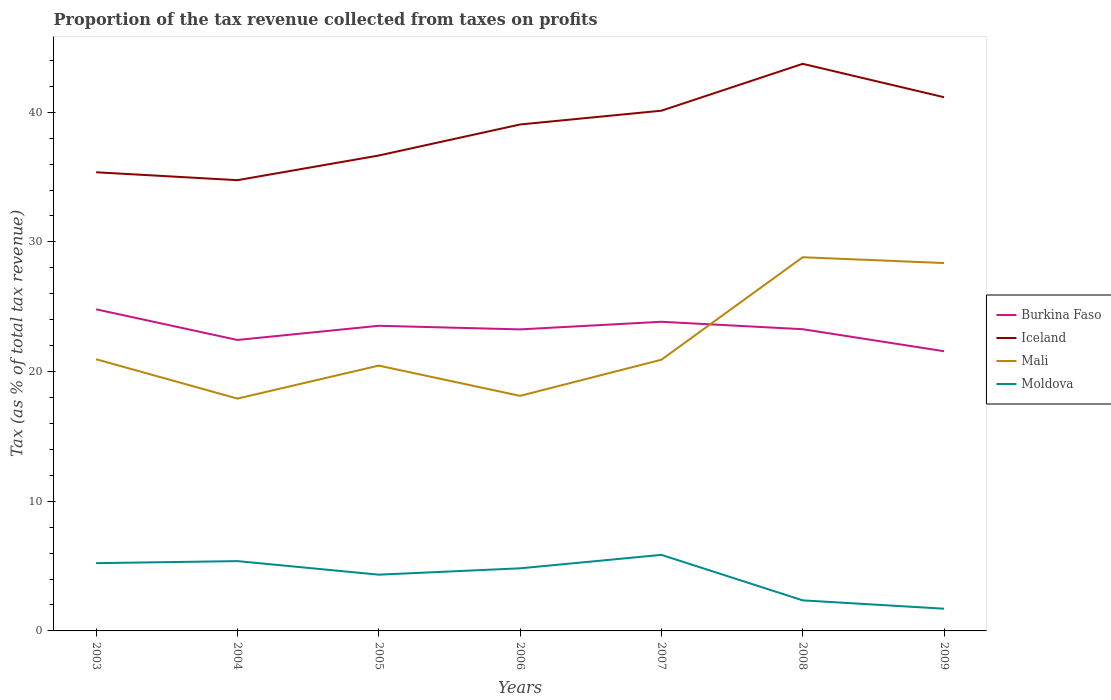Is the number of lines equal to the number of legend labels?
Provide a short and direct response. Yes. Across all years, what is the maximum proportion of the tax revenue collected in Burkina Faso?
Your answer should be compact. 21.57. In which year was the proportion of the tax revenue collected in Burkina Faso maximum?
Offer a very short reply. 2009. What is the total proportion of the tax revenue collected in Burkina Faso in the graph?
Offer a terse response. 1.54. What is the difference between the highest and the second highest proportion of the tax revenue collected in Mali?
Make the answer very short. 10.9. What is the difference between the highest and the lowest proportion of the tax revenue collected in Mali?
Give a very brief answer. 2. How many lines are there?
Offer a very short reply. 4. What is the difference between two consecutive major ticks on the Y-axis?
Ensure brevity in your answer.  10. Are the values on the major ticks of Y-axis written in scientific E-notation?
Provide a succinct answer. No. Where does the legend appear in the graph?
Your answer should be compact. Center right. How many legend labels are there?
Your response must be concise. 4. How are the legend labels stacked?
Keep it short and to the point. Vertical. What is the title of the graph?
Your response must be concise. Proportion of the tax revenue collected from taxes on profits. Does "Latin America(developing only)" appear as one of the legend labels in the graph?
Make the answer very short. No. What is the label or title of the X-axis?
Provide a short and direct response. Years. What is the label or title of the Y-axis?
Offer a very short reply. Tax (as % of total tax revenue). What is the Tax (as % of total tax revenue) of Burkina Faso in 2003?
Keep it short and to the point. 24.8. What is the Tax (as % of total tax revenue) in Iceland in 2003?
Make the answer very short. 35.37. What is the Tax (as % of total tax revenue) of Mali in 2003?
Offer a very short reply. 20.95. What is the Tax (as % of total tax revenue) of Moldova in 2003?
Keep it short and to the point. 5.23. What is the Tax (as % of total tax revenue) in Burkina Faso in 2004?
Offer a very short reply. 22.44. What is the Tax (as % of total tax revenue) of Iceland in 2004?
Offer a terse response. 34.76. What is the Tax (as % of total tax revenue) of Mali in 2004?
Give a very brief answer. 17.92. What is the Tax (as % of total tax revenue) of Moldova in 2004?
Offer a terse response. 5.38. What is the Tax (as % of total tax revenue) of Burkina Faso in 2005?
Provide a succinct answer. 23.53. What is the Tax (as % of total tax revenue) of Iceland in 2005?
Provide a short and direct response. 36.66. What is the Tax (as % of total tax revenue) of Mali in 2005?
Offer a very short reply. 20.46. What is the Tax (as % of total tax revenue) of Moldova in 2005?
Ensure brevity in your answer.  4.34. What is the Tax (as % of total tax revenue) of Burkina Faso in 2006?
Your response must be concise. 23.26. What is the Tax (as % of total tax revenue) of Iceland in 2006?
Offer a very short reply. 39.06. What is the Tax (as % of total tax revenue) in Mali in 2006?
Offer a very short reply. 18.13. What is the Tax (as % of total tax revenue) in Moldova in 2006?
Offer a very short reply. 4.83. What is the Tax (as % of total tax revenue) of Burkina Faso in 2007?
Ensure brevity in your answer.  23.84. What is the Tax (as % of total tax revenue) of Iceland in 2007?
Offer a very short reply. 40.12. What is the Tax (as % of total tax revenue) of Mali in 2007?
Your response must be concise. 20.91. What is the Tax (as % of total tax revenue) of Moldova in 2007?
Your answer should be very brief. 5.87. What is the Tax (as % of total tax revenue) in Burkina Faso in 2008?
Your answer should be very brief. 23.27. What is the Tax (as % of total tax revenue) in Iceland in 2008?
Give a very brief answer. 43.74. What is the Tax (as % of total tax revenue) of Mali in 2008?
Provide a short and direct response. 28.82. What is the Tax (as % of total tax revenue) of Moldova in 2008?
Provide a succinct answer. 2.36. What is the Tax (as % of total tax revenue) in Burkina Faso in 2009?
Provide a succinct answer. 21.57. What is the Tax (as % of total tax revenue) of Iceland in 2009?
Keep it short and to the point. 41.16. What is the Tax (as % of total tax revenue) in Mali in 2009?
Offer a very short reply. 28.37. What is the Tax (as % of total tax revenue) in Moldova in 2009?
Ensure brevity in your answer.  1.71. Across all years, what is the maximum Tax (as % of total tax revenue) of Burkina Faso?
Offer a very short reply. 24.8. Across all years, what is the maximum Tax (as % of total tax revenue) in Iceland?
Provide a short and direct response. 43.74. Across all years, what is the maximum Tax (as % of total tax revenue) in Mali?
Keep it short and to the point. 28.82. Across all years, what is the maximum Tax (as % of total tax revenue) of Moldova?
Give a very brief answer. 5.87. Across all years, what is the minimum Tax (as % of total tax revenue) in Burkina Faso?
Your answer should be compact. 21.57. Across all years, what is the minimum Tax (as % of total tax revenue) in Iceland?
Ensure brevity in your answer.  34.76. Across all years, what is the minimum Tax (as % of total tax revenue) of Mali?
Provide a succinct answer. 17.92. Across all years, what is the minimum Tax (as % of total tax revenue) in Moldova?
Your answer should be very brief. 1.71. What is the total Tax (as % of total tax revenue) in Burkina Faso in the graph?
Give a very brief answer. 162.71. What is the total Tax (as % of total tax revenue) of Iceland in the graph?
Your answer should be compact. 270.88. What is the total Tax (as % of total tax revenue) of Mali in the graph?
Give a very brief answer. 155.57. What is the total Tax (as % of total tax revenue) in Moldova in the graph?
Provide a succinct answer. 29.71. What is the difference between the Tax (as % of total tax revenue) of Burkina Faso in 2003 and that in 2004?
Offer a very short reply. 2.36. What is the difference between the Tax (as % of total tax revenue) in Iceland in 2003 and that in 2004?
Offer a very short reply. 0.61. What is the difference between the Tax (as % of total tax revenue) of Mali in 2003 and that in 2004?
Provide a succinct answer. 3.03. What is the difference between the Tax (as % of total tax revenue) of Moldova in 2003 and that in 2004?
Give a very brief answer. -0.16. What is the difference between the Tax (as % of total tax revenue) of Burkina Faso in 2003 and that in 2005?
Offer a terse response. 1.27. What is the difference between the Tax (as % of total tax revenue) in Iceland in 2003 and that in 2005?
Give a very brief answer. -1.29. What is the difference between the Tax (as % of total tax revenue) in Mali in 2003 and that in 2005?
Your response must be concise. 0.49. What is the difference between the Tax (as % of total tax revenue) of Moldova in 2003 and that in 2005?
Provide a succinct answer. 0.89. What is the difference between the Tax (as % of total tax revenue) in Burkina Faso in 2003 and that in 2006?
Make the answer very short. 1.55. What is the difference between the Tax (as % of total tax revenue) of Iceland in 2003 and that in 2006?
Make the answer very short. -3.69. What is the difference between the Tax (as % of total tax revenue) of Mali in 2003 and that in 2006?
Provide a succinct answer. 2.82. What is the difference between the Tax (as % of total tax revenue) of Moldova in 2003 and that in 2006?
Your answer should be very brief. 0.4. What is the difference between the Tax (as % of total tax revenue) in Burkina Faso in 2003 and that in 2007?
Provide a short and direct response. 0.96. What is the difference between the Tax (as % of total tax revenue) in Iceland in 2003 and that in 2007?
Give a very brief answer. -4.75. What is the difference between the Tax (as % of total tax revenue) in Mali in 2003 and that in 2007?
Your answer should be compact. 0.04. What is the difference between the Tax (as % of total tax revenue) of Moldova in 2003 and that in 2007?
Offer a very short reply. -0.64. What is the difference between the Tax (as % of total tax revenue) in Burkina Faso in 2003 and that in 2008?
Offer a terse response. 1.54. What is the difference between the Tax (as % of total tax revenue) in Iceland in 2003 and that in 2008?
Keep it short and to the point. -8.36. What is the difference between the Tax (as % of total tax revenue) of Mali in 2003 and that in 2008?
Your answer should be compact. -7.87. What is the difference between the Tax (as % of total tax revenue) of Moldova in 2003 and that in 2008?
Keep it short and to the point. 2.87. What is the difference between the Tax (as % of total tax revenue) of Burkina Faso in 2003 and that in 2009?
Your answer should be compact. 3.23. What is the difference between the Tax (as % of total tax revenue) of Iceland in 2003 and that in 2009?
Ensure brevity in your answer.  -5.79. What is the difference between the Tax (as % of total tax revenue) in Mali in 2003 and that in 2009?
Give a very brief answer. -7.42. What is the difference between the Tax (as % of total tax revenue) in Moldova in 2003 and that in 2009?
Provide a short and direct response. 3.51. What is the difference between the Tax (as % of total tax revenue) of Burkina Faso in 2004 and that in 2005?
Ensure brevity in your answer.  -1.09. What is the difference between the Tax (as % of total tax revenue) in Iceland in 2004 and that in 2005?
Offer a very short reply. -1.9. What is the difference between the Tax (as % of total tax revenue) of Mali in 2004 and that in 2005?
Offer a very short reply. -2.54. What is the difference between the Tax (as % of total tax revenue) in Moldova in 2004 and that in 2005?
Offer a terse response. 1.05. What is the difference between the Tax (as % of total tax revenue) in Burkina Faso in 2004 and that in 2006?
Give a very brief answer. -0.82. What is the difference between the Tax (as % of total tax revenue) of Iceland in 2004 and that in 2006?
Make the answer very short. -4.3. What is the difference between the Tax (as % of total tax revenue) of Mali in 2004 and that in 2006?
Offer a terse response. -0.21. What is the difference between the Tax (as % of total tax revenue) in Moldova in 2004 and that in 2006?
Make the answer very short. 0.56. What is the difference between the Tax (as % of total tax revenue) in Burkina Faso in 2004 and that in 2007?
Your answer should be very brief. -1.4. What is the difference between the Tax (as % of total tax revenue) of Iceland in 2004 and that in 2007?
Your answer should be compact. -5.36. What is the difference between the Tax (as % of total tax revenue) of Mali in 2004 and that in 2007?
Provide a short and direct response. -3. What is the difference between the Tax (as % of total tax revenue) in Moldova in 2004 and that in 2007?
Make the answer very short. -0.48. What is the difference between the Tax (as % of total tax revenue) in Burkina Faso in 2004 and that in 2008?
Your answer should be very brief. -0.83. What is the difference between the Tax (as % of total tax revenue) in Iceland in 2004 and that in 2008?
Offer a very short reply. -8.97. What is the difference between the Tax (as % of total tax revenue) of Mali in 2004 and that in 2008?
Offer a very short reply. -10.9. What is the difference between the Tax (as % of total tax revenue) of Moldova in 2004 and that in 2008?
Offer a very short reply. 3.03. What is the difference between the Tax (as % of total tax revenue) in Burkina Faso in 2004 and that in 2009?
Give a very brief answer. 0.87. What is the difference between the Tax (as % of total tax revenue) of Iceland in 2004 and that in 2009?
Your answer should be compact. -6.4. What is the difference between the Tax (as % of total tax revenue) in Mali in 2004 and that in 2009?
Your answer should be compact. -10.45. What is the difference between the Tax (as % of total tax revenue) of Moldova in 2004 and that in 2009?
Your answer should be very brief. 3.67. What is the difference between the Tax (as % of total tax revenue) in Burkina Faso in 2005 and that in 2006?
Make the answer very short. 0.28. What is the difference between the Tax (as % of total tax revenue) of Iceland in 2005 and that in 2006?
Your answer should be very brief. -2.39. What is the difference between the Tax (as % of total tax revenue) in Mali in 2005 and that in 2006?
Keep it short and to the point. 2.33. What is the difference between the Tax (as % of total tax revenue) of Moldova in 2005 and that in 2006?
Make the answer very short. -0.49. What is the difference between the Tax (as % of total tax revenue) of Burkina Faso in 2005 and that in 2007?
Provide a succinct answer. -0.31. What is the difference between the Tax (as % of total tax revenue) in Iceland in 2005 and that in 2007?
Offer a very short reply. -3.46. What is the difference between the Tax (as % of total tax revenue) of Mali in 2005 and that in 2007?
Provide a short and direct response. -0.45. What is the difference between the Tax (as % of total tax revenue) of Moldova in 2005 and that in 2007?
Offer a terse response. -1.53. What is the difference between the Tax (as % of total tax revenue) in Burkina Faso in 2005 and that in 2008?
Ensure brevity in your answer.  0.26. What is the difference between the Tax (as % of total tax revenue) in Iceland in 2005 and that in 2008?
Give a very brief answer. -7.07. What is the difference between the Tax (as % of total tax revenue) in Mali in 2005 and that in 2008?
Your answer should be compact. -8.36. What is the difference between the Tax (as % of total tax revenue) in Moldova in 2005 and that in 2008?
Your answer should be compact. 1.98. What is the difference between the Tax (as % of total tax revenue) in Burkina Faso in 2005 and that in 2009?
Provide a short and direct response. 1.96. What is the difference between the Tax (as % of total tax revenue) in Iceland in 2005 and that in 2009?
Give a very brief answer. -4.5. What is the difference between the Tax (as % of total tax revenue) of Mali in 2005 and that in 2009?
Give a very brief answer. -7.91. What is the difference between the Tax (as % of total tax revenue) of Moldova in 2005 and that in 2009?
Offer a very short reply. 2.62. What is the difference between the Tax (as % of total tax revenue) of Burkina Faso in 2006 and that in 2007?
Offer a very short reply. -0.59. What is the difference between the Tax (as % of total tax revenue) in Iceland in 2006 and that in 2007?
Provide a short and direct response. -1.06. What is the difference between the Tax (as % of total tax revenue) of Mali in 2006 and that in 2007?
Your answer should be compact. -2.79. What is the difference between the Tax (as % of total tax revenue) in Moldova in 2006 and that in 2007?
Keep it short and to the point. -1.04. What is the difference between the Tax (as % of total tax revenue) of Burkina Faso in 2006 and that in 2008?
Your answer should be very brief. -0.01. What is the difference between the Tax (as % of total tax revenue) of Iceland in 2006 and that in 2008?
Offer a very short reply. -4.68. What is the difference between the Tax (as % of total tax revenue) of Mali in 2006 and that in 2008?
Offer a very short reply. -10.69. What is the difference between the Tax (as % of total tax revenue) in Moldova in 2006 and that in 2008?
Keep it short and to the point. 2.47. What is the difference between the Tax (as % of total tax revenue) in Burkina Faso in 2006 and that in 2009?
Your answer should be compact. 1.68. What is the difference between the Tax (as % of total tax revenue) in Iceland in 2006 and that in 2009?
Offer a very short reply. -2.1. What is the difference between the Tax (as % of total tax revenue) in Mali in 2006 and that in 2009?
Offer a very short reply. -10.24. What is the difference between the Tax (as % of total tax revenue) of Moldova in 2006 and that in 2009?
Offer a terse response. 3.12. What is the difference between the Tax (as % of total tax revenue) of Burkina Faso in 2007 and that in 2008?
Provide a succinct answer. 0.57. What is the difference between the Tax (as % of total tax revenue) in Iceland in 2007 and that in 2008?
Your response must be concise. -3.62. What is the difference between the Tax (as % of total tax revenue) in Mali in 2007 and that in 2008?
Offer a terse response. -7.91. What is the difference between the Tax (as % of total tax revenue) of Moldova in 2007 and that in 2008?
Your answer should be very brief. 3.51. What is the difference between the Tax (as % of total tax revenue) of Burkina Faso in 2007 and that in 2009?
Provide a succinct answer. 2.27. What is the difference between the Tax (as % of total tax revenue) of Iceland in 2007 and that in 2009?
Your answer should be compact. -1.04. What is the difference between the Tax (as % of total tax revenue) of Mali in 2007 and that in 2009?
Provide a short and direct response. -7.46. What is the difference between the Tax (as % of total tax revenue) of Moldova in 2007 and that in 2009?
Keep it short and to the point. 4.15. What is the difference between the Tax (as % of total tax revenue) of Burkina Faso in 2008 and that in 2009?
Provide a succinct answer. 1.7. What is the difference between the Tax (as % of total tax revenue) in Iceland in 2008 and that in 2009?
Offer a terse response. 2.58. What is the difference between the Tax (as % of total tax revenue) in Mali in 2008 and that in 2009?
Offer a terse response. 0.45. What is the difference between the Tax (as % of total tax revenue) in Moldova in 2008 and that in 2009?
Make the answer very short. 0.64. What is the difference between the Tax (as % of total tax revenue) in Burkina Faso in 2003 and the Tax (as % of total tax revenue) in Iceland in 2004?
Your answer should be compact. -9.96. What is the difference between the Tax (as % of total tax revenue) of Burkina Faso in 2003 and the Tax (as % of total tax revenue) of Mali in 2004?
Keep it short and to the point. 6.89. What is the difference between the Tax (as % of total tax revenue) in Burkina Faso in 2003 and the Tax (as % of total tax revenue) in Moldova in 2004?
Provide a short and direct response. 19.42. What is the difference between the Tax (as % of total tax revenue) of Iceland in 2003 and the Tax (as % of total tax revenue) of Mali in 2004?
Provide a succinct answer. 17.45. What is the difference between the Tax (as % of total tax revenue) in Iceland in 2003 and the Tax (as % of total tax revenue) in Moldova in 2004?
Provide a short and direct response. 29.99. What is the difference between the Tax (as % of total tax revenue) in Mali in 2003 and the Tax (as % of total tax revenue) in Moldova in 2004?
Your response must be concise. 15.57. What is the difference between the Tax (as % of total tax revenue) of Burkina Faso in 2003 and the Tax (as % of total tax revenue) of Iceland in 2005?
Provide a short and direct response. -11.86. What is the difference between the Tax (as % of total tax revenue) of Burkina Faso in 2003 and the Tax (as % of total tax revenue) of Mali in 2005?
Give a very brief answer. 4.34. What is the difference between the Tax (as % of total tax revenue) in Burkina Faso in 2003 and the Tax (as % of total tax revenue) in Moldova in 2005?
Your answer should be compact. 20.47. What is the difference between the Tax (as % of total tax revenue) in Iceland in 2003 and the Tax (as % of total tax revenue) in Mali in 2005?
Offer a very short reply. 14.91. What is the difference between the Tax (as % of total tax revenue) in Iceland in 2003 and the Tax (as % of total tax revenue) in Moldova in 2005?
Make the answer very short. 31.03. What is the difference between the Tax (as % of total tax revenue) of Mali in 2003 and the Tax (as % of total tax revenue) of Moldova in 2005?
Provide a short and direct response. 16.62. What is the difference between the Tax (as % of total tax revenue) of Burkina Faso in 2003 and the Tax (as % of total tax revenue) of Iceland in 2006?
Give a very brief answer. -14.25. What is the difference between the Tax (as % of total tax revenue) of Burkina Faso in 2003 and the Tax (as % of total tax revenue) of Mali in 2006?
Make the answer very short. 6.68. What is the difference between the Tax (as % of total tax revenue) of Burkina Faso in 2003 and the Tax (as % of total tax revenue) of Moldova in 2006?
Make the answer very short. 19.98. What is the difference between the Tax (as % of total tax revenue) of Iceland in 2003 and the Tax (as % of total tax revenue) of Mali in 2006?
Keep it short and to the point. 17.24. What is the difference between the Tax (as % of total tax revenue) in Iceland in 2003 and the Tax (as % of total tax revenue) in Moldova in 2006?
Your answer should be very brief. 30.54. What is the difference between the Tax (as % of total tax revenue) of Mali in 2003 and the Tax (as % of total tax revenue) of Moldova in 2006?
Offer a very short reply. 16.12. What is the difference between the Tax (as % of total tax revenue) of Burkina Faso in 2003 and the Tax (as % of total tax revenue) of Iceland in 2007?
Keep it short and to the point. -15.32. What is the difference between the Tax (as % of total tax revenue) in Burkina Faso in 2003 and the Tax (as % of total tax revenue) in Mali in 2007?
Ensure brevity in your answer.  3.89. What is the difference between the Tax (as % of total tax revenue) of Burkina Faso in 2003 and the Tax (as % of total tax revenue) of Moldova in 2007?
Your answer should be very brief. 18.94. What is the difference between the Tax (as % of total tax revenue) in Iceland in 2003 and the Tax (as % of total tax revenue) in Mali in 2007?
Ensure brevity in your answer.  14.46. What is the difference between the Tax (as % of total tax revenue) in Iceland in 2003 and the Tax (as % of total tax revenue) in Moldova in 2007?
Keep it short and to the point. 29.51. What is the difference between the Tax (as % of total tax revenue) in Mali in 2003 and the Tax (as % of total tax revenue) in Moldova in 2007?
Provide a short and direct response. 15.09. What is the difference between the Tax (as % of total tax revenue) in Burkina Faso in 2003 and the Tax (as % of total tax revenue) in Iceland in 2008?
Offer a very short reply. -18.93. What is the difference between the Tax (as % of total tax revenue) of Burkina Faso in 2003 and the Tax (as % of total tax revenue) of Mali in 2008?
Offer a very short reply. -4.02. What is the difference between the Tax (as % of total tax revenue) of Burkina Faso in 2003 and the Tax (as % of total tax revenue) of Moldova in 2008?
Your response must be concise. 22.45. What is the difference between the Tax (as % of total tax revenue) in Iceland in 2003 and the Tax (as % of total tax revenue) in Mali in 2008?
Offer a terse response. 6.55. What is the difference between the Tax (as % of total tax revenue) in Iceland in 2003 and the Tax (as % of total tax revenue) in Moldova in 2008?
Offer a very short reply. 33.02. What is the difference between the Tax (as % of total tax revenue) in Mali in 2003 and the Tax (as % of total tax revenue) in Moldova in 2008?
Make the answer very short. 18.6. What is the difference between the Tax (as % of total tax revenue) of Burkina Faso in 2003 and the Tax (as % of total tax revenue) of Iceland in 2009?
Give a very brief answer. -16.36. What is the difference between the Tax (as % of total tax revenue) of Burkina Faso in 2003 and the Tax (as % of total tax revenue) of Mali in 2009?
Provide a short and direct response. -3.57. What is the difference between the Tax (as % of total tax revenue) of Burkina Faso in 2003 and the Tax (as % of total tax revenue) of Moldova in 2009?
Ensure brevity in your answer.  23.09. What is the difference between the Tax (as % of total tax revenue) of Iceland in 2003 and the Tax (as % of total tax revenue) of Mali in 2009?
Offer a very short reply. 7. What is the difference between the Tax (as % of total tax revenue) in Iceland in 2003 and the Tax (as % of total tax revenue) in Moldova in 2009?
Your response must be concise. 33.66. What is the difference between the Tax (as % of total tax revenue) of Mali in 2003 and the Tax (as % of total tax revenue) of Moldova in 2009?
Give a very brief answer. 19.24. What is the difference between the Tax (as % of total tax revenue) of Burkina Faso in 2004 and the Tax (as % of total tax revenue) of Iceland in 2005?
Ensure brevity in your answer.  -14.23. What is the difference between the Tax (as % of total tax revenue) of Burkina Faso in 2004 and the Tax (as % of total tax revenue) of Mali in 2005?
Offer a very short reply. 1.98. What is the difference between the Tax (as % of total tax revenue) of Burkina Faso in 2004 and the Tax (as % of total tax revenue) of Moldova in 2005?
Offer a very short reply. 18.1. What is the difference between the Tax (as % of total tax revenue) of Iceland in 2004 and the Tax (as % of total tax revenue) of Mali in 2005?
Ensure brevity in your answer.  14.3. What is the difference between the Tax (as % of total tax revenue) in Iceland in 2004 and the Tax (as % of total tax revenue) in Moldova in 2005?
Make the answer very short. 30.43. What is the difference between the Tax (as % of total tax revenue) of Mali in 2004 and the Tax (as % of total tax revenue) of Moldova in 2005?
Provide a short and direct response. 13.58. What is the difference between the Tax (as % of total tax revenue) in Burkina Faso in 2004 and the Tax (as % of total tax revenue) in Iceland in 2006?
Give a very brief answer. -16.62. What is the difference between the Tax (as % of total tax revenue) in Burkina Faso in 2004 and the Tax (as % of total tax revenue) in Mali in 2006?
Give a very brief answer. 4.31. What is the difference between the Tax (as % of total tax revenue) in Burkina Faso in 2004 and the Tax (as % of total tax revenue) in Moldova in 2006?
Ensure brevity in your answer.  17.61. What is the difference between the Tax (as % of total tax revenue) in Iceland in 2004 and the Tax (as % of total tax revenue) in Mali in 2006?
Provide a short and direct response. 16.63. What is the difference between the Tax (as % of total tax revenue) of Iceland in 2004 and the Tax (as % of total tax revenue) of Moldova in 2006?
Your answer should be compact. 29.93. What is the difference between the Tax (as % of total tax revenue) in Mali in 2004 and the Tax (as % of total tax revenue) in Moldova in 2006?
Your answer should be very brief. 13.09. What is the difference between the Tax (as % of total tax revenue) in Burkina Faso in 2004 and the Tax (as % of total tax revenue) in Iceland in 2007?
Give a very brief answer. -17.68. What is the difference between the Tax (as % of total tax revenue) in Burkina Faso in 2004 and the Tax (as % of total tax revenue) in Mali in 2007?
Keep it short and to the point. 1.53. What is the difference between the Tax (as % of total tax revenue) of Burkina Faso in 2004 and the Tax (as % of total tax revenue) of Moldova in 2007?
Provide a short and direct response. 16.57. What is the difference between the Tax (as % of total tax revenue) of Iceland in 2004 and the Tax (as % of total tax revenue) of Mali in 2007?
Give a very brief answer. 13.85. What is the difference between the Tax (as % of total tax revenue) in Iceland in 2004 and the Tax (as % of total tax revenue) in Moldova in 2007?
Your answer should be compact. 28.9. What is the difference between the Tax (as % of total tax revenue) of Mali in 2004 and the Tax (as % of total tax revenue) of Moldova in 2007?
Provide a short and direct response. 12.05. What is the difference between the Tax (as % of total tax revenue) in Burkina Faso in 2004 and the Tax (as % of total tax revenue) in Iceland in 2008?
Offer a terse response. -21.3. What is the difference between the Tax (as % of total tax revenue) in Burkina Faso in 2004 and the Tax (as % of total tax revenue) in Mali in 2008?
Keep it short and to the point. -6.38. What is the difference between the Tax (as % of total tax revenue) in Burkina Faso in 2004 and the Tax (as % of total tax revenue) in Moldova in 2008?
Keep it short and to the point. 20.08. What is the difference between the Tax (as % of total tax revenue) in Iceland in 2004 and the Tax (as % of total tax revenue) in Mali in 2008?
Provide a short and direct response. 5.94. What is the difference between the Tax (as % of total tax revenue) in Iceland in 2004 and the Tax (as % of total tax revenue) in Moldova in 2008?
Give a very brief answer. 32.41. What is the difference between the Tax (as % of total tax revenue) of Mali in 2004 and the Tax (as % of total tax revenue) of Moldova in 2008?
Make the answer very short. 15.56. What is the difference between the Tax (as % of total tax revenue) of Burkina Faso in 2004 and the Tax (as % of total tax revenue) of Iceland in 2009?
Offer a very short reply. -18.72. What is the difference between the Tax (as % of total tax revenue) of Burkina Faso in 2004 and the Tax (as % of total tax revenue) of Mali in 2009?
Ensure brevity in your answer.  -5.93. What is the difference between the Tax (as % of total tax revenue) in Burkina Faso in 2004 and the Tax (as % of total tax revenue) in Moldova in 2009?
Offer a very short reply. 20.73. What is the difference between the Tax (as % of total tax revenue) of Iceland in 2004 and the Tax (as % of total tax revenue) of Mali in 2009?
Your answer should be compact. 6.39. What is the difference between the Tax (as % of total tax revenue) of Iceland in 2004 and the Tax (as % of total tax revenue) of Moldova in 2009?
Your answer should be compact. 33.05. What is the difference between the Tax (as % of total tax revenue) of Mali in 2004 and the Tax (as % of total tax revenue) of Moldova in 2009?
Provide a short and direct response. 16.21. What is the difference between the Tax (as % of total tax revenue) in Burkina Faso in 2005 and the Tax (as % of total tax revenue) in Iceland in 2006?
Provide a short and direct response. -15.53. What is the difference between the Tax (as % of total tax revenue) in Burkina Faso in 2005 and the Tax (as % of total tax revenue) in Mali in 2006?
Provide a short and direct response. 5.4. What is the difference between the Tax (as % of total tax revenue) of Burkina Faso in 2005 and the Tax (as % of total tax revenue) of Moldova in 2006?
Your answer should be very brief. 18.7. What is the difference between the Tax (as % of total tax revenue) in Iceland in 2005 and the Tax (as % of total tax revenue) in Mali in 2006?
Provide a succinct answer. 18.54. What is the difference between the Tax (as % of total tax revenue) in Iceland in 2005 and the Tax (as % of total tax revenue) in Moldova in 2006?
Your answer should be very brief. 31.84. What is the difference between the Tax (as % of total tax revenue) of Mali in 2005 and the Tax (as % of total tax revenue) of Moldova in 2006?
Make the answer very short. 15.63. What is the difference between the Tax (as % of total tax revenue) in Burkina Faso in 2005 and the Tax (as % of total tax revenue) in Iceland in 2007?
Your response must be concise. -16.59. What is the difference between the Tax (as % of total tax revenue) in Burkina Faso in 2005 and the Tax (as % of total tax revenue) in Mali in 2007?
Your response must be concise. 2.62. What is the difference between the Tax (as % of total tax revenue) of Burkina Faso in 2005 and the Tax (as % of total tax revenue) of Moldova in 2007?
Provide a short and direct response. 17.67. What is the difference between the Tax (as % of total tax revenue) of Iceland in 2005 and the Tax (as % of total tax revenue) of Mali in 2007?
Your answer should be compact. 15.75. What is the difference between the Tax (as % of total tax revenue) of Iceland in 2005 and the Tax (as % of total tax revenue) of Moldova in 2007?
Ensure brevity in your answer.  30.8. What is the difference between the Tax (as % of total tax revenue) of Mali in 2005 and the Tax (as % of total tax revenue) of Moldova in 2007?
Provide a succinct answer. 14.6. What is the difference between the Tax (as % of total tax revenue) of Burkina Faso in 2005 and the Tax (as % of total tax revenue) of Iceland in 2008?
Give a very brief answer. -20.2. What is the difference between the Tax (as % of total tax revenue) of Burkina Faso in 2005 and the Tax (as % of total tax revenue) of Mali in 2008?
Give a very brief answer. -5.29. What is the difference between the Tax (as % of total tax revenue) in Burkina Faso in 2005 and the Tax (as % of total tax revenue) in Moldova in 2008?
Ensure brevity in your answer.  21.18. What is the difference between the Tax (as % of total tax revenue) in Iceland in 2005 and the Tax (as % of total tax revenue) in Mali in 2008?
Make the answer very short. 7.84. What is the difference between the Tax (as % of total tax revenue) in Iceland in 2005 and the Tax (as % of total tax revenue) in Moldova in 2008?
Your answer should be compact. 34.31. What is the difference between the Tax (as % of total tax revenue) in Mali in 2005 and the Tax (as % of total tax revenue) in Moldova in 2008?
Give a very brief answer. 18.11. What is the difference between the Tax (as % of total tax revenue) of Burkina Faso in 2005 and the Tax (as % of total tax revenue) of Iceland in 2009?
Your answer should be compact. -17.63. What is the difference between the Tax (as % of total tax revenue) in Burkina Faso in 2005 and the Tax (as % of total tax revenue) in Mali in 2009?
Your answer should be very brief. -4.84. What is the difference between the Tax (as % of total tax revenue) in Burkina Faso in 2005 and the Tax (as % of total tax revenue) in Moldova in 2009?
Your answer should be very brief. 21.82. What is the difference between the Tax (as % of total tax revenue) in Iceland in 2005 and the Tax (as % of total tax revenue) in Mali in 2009?
Provide a succinct answer. 8.29. What is the difference between the Tax (as % of total tax revenue) in Iceland in 2005 and the Tax (as % of total tax revenue) in Moldova in 2009?
Keep it short and to the point. 34.95. What is the difference between the Tax (as % of total tax revenue) in Mali in 2005 and the Tax (as % of total tax revenue) in Moldova in 2009?
Keep it short and to the point. 18.75. What is the difference between the Tax (as % of total tax revenue) of Burkina Faso in 2006 and the Tax (as % of total tax revenue) of Iceland in 2007?
Your answer should be compact. -16.87. What is the difference between the Tax (as % of total tax revenue) of Burkina Faso in 2006 and the Tax (as % of total tax revenue) of Mali in 2007?
Offer a very short reply. 2.34. What is the difference between the Tax (as % of total tax revenue) in Burkina Faso in 2006 and the Tax (as % of total tax revenue) in Moldova in 2007?
Make the answer very short. 17.39. What is the difference between the Tax (as % of total tax revenue) in Iceland in 2006 and the Tax (as % of total tax revenue) in Mali in 2007?
Provide a succinct answer. 18.14. What is the difference between the Tax (as % of total tax revenue) in Iceland in 2006 and the Tax (as % of total tax revenue) in Moldova in 2007?
Provide a succinct answer. 33.19. What is the difference between the Tax (as % of total tax revenue) in Mali in 2006 and the Tax (as % of total tax revenue) in Moldova in 2007?
Your answer should be very brief. 12.26. What is the difference between the Tax (as % of total tax revenue) of Burkina Faso in 2006 and the Tax (as % of total tax revenue) of Iceland in 2008?
Your answer should be compact. -20.48. What is the difference between the Tax (as % of total tax revenue) in Burkina Faso in 2006 and the Tax (as % of total tax revenue) in Mali in 2008?
Your answer should be compact. -5.57. What is the difference between the Tax (as % of total tax revenue) in Burkina Faso in 2006 and the Tax (as % of total tax revenue) in Moldova in 2008?
Make the answer very short. 20.9. What is the difference between the Tax (as % of total tax revenue) in Iceland in 2006 and the Tax (as % of total tax revenue) in Mali in 2008?
Your response must be concise. 10.24. What is the difference between the Tax (as % of total tax revenue) in Iceland in 2006 and the Tax (as % of total tax revenue) in Moldova in 2008?
Provide a succinct answer. 36.7. What is the difference between the Tax (as % of total tax revenue) of Mali in 2006 and the Tax (as % of total tax revenue) of Moldova in 2008?
Give a very brief answer. 15.77. What is the difference between the Tax (as % of total tax revenue) of Burkina Faso in 2006 and the Tax (as % of total tax revenue) of Iceland in 2009?
Make the answer very short. -17.91. What is the difference between the Tax (as % of total tax revenue) of Burkina Faso in 2006 and the Tax (as % of total tax revenue) of Mali in 2009?
Give a very brief answer. -5.12. What is the difference between the Tax (as % of total tax revenue) of Burkina Faso in 2006 and the Tax (as % of total tax revenue) of Moldova in 2009?
Give a very brief answer. 21.54. What is the difference between the Tax (as % of total tax revenue) of Iceland in 2006 and the Tax (as % of total tax revenue) of Mali in 2009?
Your answer should be compact. 10.69. What is the difference between the Tax (as % of total tax revenue) in Iceland in 2006 and the Tax (as % of total tax revenue) in Moldova in 2009?
Offer a terse response. 37.35. What is the difference between the Tax (as % of total tax revenue) of Mali in 2006 and the Tax (as % of total tax revenue) of Moldova in 2009?
Ensure brevity in your answer.  16.42. What is the difference between the Tax (as % of total tax revenue) of Burkina Faso in 2007 and the Tax (as % of total tax revenue) of Iceland in 2008?
Your response must be concise. -19.89. What is the difference between the Tax (as % of total tax revenue) of Burkina Faso in 2007 and the Tax (as % of total tax revenue) of Mali in 2008?
Your answer should be compact. -4.98. What is the difference between the Tax (as % of total tax revenue) in Burkina Faso in 2007 and the Tax (as % of total tax revenue) in Moldova in 2008?
Keep it short and to the point. 21.48. What is the difference between the Tax (as % of total tax revenue) of Iceland in 2007 and the Tax (as % of total tax revenue) of Mali in 2008?
Keep it short and to the point. 11.3. What is the difference between the Tax (as % of total tax revenue) in Iceland in 2007 and the Tax (as % of total tax revenue) in Moldova in 2008?
Offer a very short reply. 37.76. What is the difference between the Tax (as % of total tax revenue) in Mali in 2007 and the Tax (as % of total tax revenue) in Moldova in 2008?
Ensure brevity in your answer.  18.56. What is the difference between the Tax (as % of total tax revenue) in Burkina Faso in 2007 and the Tax (as % of total tax revenue) in Iceland in 2009?
Keep it short and to the point. -17.32. What is the difference between the Tax (as % of total tax revenue) of Burkina Faso in 2007 and the Tax (as % of total tax revenue) of Mali in 2009?
Make the answer very short. -4.53. What is the difference between the Tax (as % of total tax revenue) in Burkina Faso in 2007 and the Tax (as % of total tax revenue) in Moldova in 2009?
Give a very brief answer. 22.13. What is the difference between the Tax (as % of total tax revenue) of Iceland in 2007 and the Tax (as % of total tax revenue) of Mali in 2009?
Your response must be concise. 11.75. What is the difference between the Tax (as % of total tax revenue) of Iceland in 2007 and the Tax (as % of total tax revenue) of Moldova in 2009?
Your answer should be compact. 38.41. What is the difference between the Tax (as % of total tax revenue) of Mali in 2007 and the Tax (as % of total tax revenue) of Moldova in 2009?
Give a very brief answer. 19.2. What is the difference between the Tax (as % of total tax revenue) in Burkina Faso in 2008 and the Tax (as % of total tax revenue) in Iceland in 2009?
Give a very brief answer. -17.89. What is the difference between the Tax (as % of total tax revenue) of Burkina Faso in 2008 and the Tax (as % of total tax revenue) of Mali in 2009?
Keep it short and to the point. -5.1. What is the difference between the Tax (as % of total tax revenue) in Burkina Faso in 2008 and the Tax (as % of total tax revenue) in Moldova in 2009?
Provide a succinct answer. 21.56. What is the difference between the Tax (as % of total tax revenue) of Iceland in 2008 and the Tax (as % of total tax revenue) of Mali in 2009?
Keep it short and to the point. 15.36. What is the difference between the Tax (as % of total tax revenue) of Iceland in 2008 and the Tax (as % of total tax revenue) of Moldova in 2009?
Your response must be concise. 42.02. What is the difference between the Tax (as % of total tax revenue) in Mali in 2008 and the Tax (as % of total tax revenue) in Moldova in 2009?
Make the answer very short. 27.11. What is the average Tax (as % of total tax revenue) of Burkina Faso per year?
Make the answer very short. 23.24. What is the average Tax (as % of total tax revenue) in Iceland per year?
Make the answer very short. 38.7. What is the average Tax (as % of total tax revenue) in Mali per year?
Offer a very short reply. 22.22. What is the average Tax (as % of total tax revenue) in Moldova per year?
Your answer should be compact. 4.24. In the year 2003, what is the difference between the Tax (as % of total tax revenue) of Burkina Faso and Tax (as % of total tax revenue) of Iceland?
Ensure brevity in your answer.  -10.57. In the year 2003, what is the difference between the Tax (as % of total tax revenue) in Burkina Faso and Tax (as % of total tax revenue) in Mali?
Provide a succinct answer. 3.85. In the year 2003, what is the difference between the Tax (as % of total tax revenue) of Burkina Faso and Tax (as % of total tax revenue) of Moldova?
Offer a terse response. 19.58. In the year 2003, what is the difference between the Tax (as % of total tax revenue) in Iceland and Tax (as % of total tax revenue) in Mali?
Ensure brevity in your answer.  14.42. In the year 2003, what is the difference between the Tax (as % of total tax revenue) of Iceland and Tax (as % of total tax revenue) of Moldova?
Provide a succinct answer. 30.15. In the year 2003, what is the difference between the Tax (as % of total tax revenue) in Mali and Tax (as % of total tax revenue) in Moldova?
Provide a succinct answer. 15.73. In the year 2004, what is the difference between the Tax (as % of total tax revenue) of Burkina Faso and Tax (as % of total tax revenue) of Iceland?
Provide a short and direct response. -12.32. In the year 2004, what is the difference between the Tax (as % of total tax revenue) of Burkina Faso and Tax (as % of total tax revenue) of Mali?
Offer a very short reply. 4.52. In the year 2004, what is the difference between the Tax (as % of total tax revenue) of Burkina Faso and Tax (as % of total tax revenue) of Moldova?
Give a very brief answer. 17.06. In the year 2004, what is the difference between the Tax (as % of total tax revenue) in Iceland and Tax (as % of total tax revenue) in Mali?
Ensure brevity in your answer.  16.84. In the year 2004, what is the difference between the Tax (as % of total tax revenue) in Iceland and Tax (as % of total tax revenue) in Moldova?
Your answer should be very brief. 29.38. In the year 2004, what is the difference between the Tax (as % of total tax revenue) in Mali and Tax (as % of total tax revenue) in Moldova?
Provide a short and direct response. 12.53. In the year 2005, what is the difference between the Tax (as % of total tax revenue) in Burkina Faso and Tax (as % of total tax revenue) in Iceland?
Offer a very short reply. -13.13. In the year 2005, what is the difference between the Tax (as % of total tax revenue) in Burkina Faso and Tax (as % of total tax revenue) in Mali?
Make the answer very short. 3.07. In the year 2005, what is the difference between the Tax (as % of total tax revenue) in Burkina Faso and Tax (as % of total tax revenue) in Moldova?
Offer a terse response. 19.2. In the year 2005, what is the difference between the Tax (as % of total tax revenue) of Iceland and Tax (as % of total tax revenue) of Mali?
Your answer should be very brief. 16.2. In the year 2005, what is the difference between the Tax (as % of total tax revenue) of Iceland and Tax (as % of total tax revenue) of Moldova?
Provide a succinct answer. 32.33. In the year 2005, what is the difference between the Tax (as % of total tax revenue) of Mali and Tax (as % of total tax revenue) of Moldova?
Provide a succinct answer. 16.12. In the year 2006, what is the difference between the Tax (as % of total tax revenue) in Burkina Faso and Tax (as % of total tax revenue) in Iceland?
Your answer should be compact. -15.8. In the year 2006, what is the difference between the Tax (as % of total tax revenue) of Burkina Faso and Tax (as % of total tax revenue) of Mali?
Make the answer very short. 5.13. In the year 2006, what is the difference between the Tax (as % of total tax revenue) in Burkina Faso and Tax (as % of total tax revenue) in Moldova?
Offer a terse response. 18.43. In the year 2006, what is the difference between the Tax (as % of total tax revenue) of Iceland and Tax (as % of total tax revenue) of Mali?
Your answer should be very brief. 20.93. In the year 2006, what is the difference between the Tax (as % of total tax revenue) of Iceland and Tax (as % of total tax revenue) of Moldova?
Provide a succinct answer. 34.23. In the year 2006, what is the difference between the Tax (as % of total tax revenue) of Mali and Tax (as % of total tax revenue) of Moldova?
Your answer should be very brief. 13.3. In the year 2007, what is the difference between the Tax (as % of total tax revenue) in Burkina Faso and Tax (as % of total tax revenue) in Iceland?
Your answer should be very brief. -16.28. In the year 2007, what is the difference between the Tax (as % of total tax revenue) in Burkina Faso and Tax (as % of total tax revenue) in Mali?
Give a very brief answer. 2.93. In the year 2007, what is the difference between the Tax (as % of total tax revenue) of Burkina Faso and Tax (as % of total tax revenue) of Moldova?
Ensure brevity in your answer.  17.98. In the year 2007, what is the difference between the Tax (as % of total tax revenue) of Iceland and Tax (as % of total tax revenue) of Mali?
Ensure brevity in your answer.  19.21. In the year 2007, what is the difference between the Tax (as % of total tax revenue) in Iceland and Tax (as % of total tax revenue) in Moldova?
Provide a short and direct response. 34.25. In the year 2007, what is the difference between the Tax (as % of total tax revenue) in Mali and Tax (as % of total tax revenue) in Moldova?
Ensure brevity in your answer.  15.05. In the year 2008, what is the difference between the Tax (as % of total tax revenue) of Burkina Faso and Tax (as % of total tax revenue) of Iceland?
Your answer should be very brief. -20.47. In the year 2008, what is the difference between the Tax (as % of total tax revenue) in Burkina Faso and Tax (as % of total tax revenue) in Mali?
Your answer should be compact. -5.55. In the year 2008, what is the difference between the Tax (as % of total tax revenue) in Burkina Faso and Tax (as % of total tax revenue) in Moldova?
Provide a succinct answer. 20.91. In the year 2008, what is the difference between the Tax (as % of total tax revenue) of Iceland and Tax (as % of total tax revenue) of Mali?
Provide a succinct answer. 14.92. In the year 2008, what is the difference between the Tax (as % of total tax revenue) of Iceland and Tax (as % of total tax revenue) of Moldova?
Keep it short and to the point. 41.38. In the year 2008, what is the difference between the Tax (as % of total tax revenue) in Mali and Tax (as % of total tax revenue) in Moldova?
Provide a short and direct response. 26.46. In the year 2009, what is the difference between the Tax (as % of total tax revenue) of Burkina Faso and Tax (as % of total tax revenue) of Iceland?
Your response must be concise. -19.59. In the year 2009, what is the difference between the Tax (as % of total tax revenue) of Burkina Faso and Tax (as % of total tax revenue) of Mali?
Make the answer very short. -6.8. In the year 2009, what is the difference between the Tax (as % of total tax revenue) of Burkina Faso and Tax (as % of total tax revenue) of Moldova?
Your answer should be compact. 19.86. In the year 2009, what is the difference between the Tax (as % of total tax revenue) in Iceland and Tax (as % of total tax revenue) in Mali?
Your answer should be compact. 12.79. In the year 2009, what is the difference between the Tax (as % of total tax revenue) of Iceland and Tax (as % of total tax revenue) of Moldova?
Keep it short and to the point. 39.45. In the year 2009, what is the difference between the Tax (as % of total tax revenue) in Mali and Tax (as % of total tax revenue) in Moldova?
Give a very brief answer. 26.66. What is the ratio of the Tax (as % of total tax revenue) of Burkina Faso in 2003 to that in 2004?
Keep it short and to the point. 1.11. What is the ratio of the Tax (as % of total tax revenue) in Iceland in 2003 to that in 2004?
Provide a short and direct response. 1.02. What is the ratio of the Tax (as % of total tax revenue) of Mali in 2003 to that in 2004?
Provide a succinct answer. 1.17. What is the ratio of the Tax (as % of total tax revenue) of Moldova in 2003 to that in 2004?
Make the answer very short. 0.97. What is the ratio of the Tax (as % of total tax revenue) of Burkina Faso in 2003 to that in 2005?
Provide a succinct answer. 1.05. What is the ratio of the Tax (as % of total tax revenue) in Iceland in 2003 to that in 2005?
Keep it short and to the point. 0.96. What is the ratio of the Tax (as % of total tax revenue) of Mali in 2003 to that in 2005?
Provide a short and direct response. 1.02. What is the ratio of the Tax (as % of total tax revenue) of Moldova in 2003 to that in 2005?
Your answer should be compact. 1.2. What is the ratio of the Tax (as % of total tax revenue) in Burkina Faso in 2003 to that in 2006?
Give a very brief answer. 1.07. What is the ratio of the Tax (as % of total tax revenue) in Iceland in 2003 to that in 2006?
Give a very brief answer. 0.91. What is the ratio of the Tax (as % of total tax revenue) in Mali in 2003 to that in 2006?
Offer a terse response. 1.16. What is the ratio of the Tax (as % of total tax revenue) of Moldova in 2003 to that in 2006?
Your response must be concise. 1.08. What is the ratio of the Tax (as % of total tax revenue) of Burkina Faso in 2003 to that in 2007?
Offer a terse response. 1.04. What is the ratio of the Tax (as % of total tax revenue) of Iceland in 2003 to that in 2007?
Keep it short and to the point. 0.88. What is the ratio of the Tax (as % of total tax revenue) of Mali in 2003 to that in 2007?
Your response must be concise. 1. What is the ratio of the Tax (as % of total tax revenue) in Moldova in 2003 to that in 2007?
Your response must be concise. 0.89. What is the ratio of the Tax (as % of total tax revenue) of Burkina Faso in 2003 to that in 2008?
Give a very brief answer. 1.07. What is the ratio of the Tax (as % of total tax revenue) in Iceland in 2003 to that in 2008?
Keep it short and to the point. 0.81. What is the ratio of the Tax (as % of total tax revenue) in Mali in 2003 to that in 2008?
Your answer should be very brief. 0.73. What is the ratio of the Tax (as % of total tax revenue) in Moldova in 2003 to that in 2008?
Offer a very short reply. 2.22. What is the ratio of the Tax (as % of total tax revenue) of Burkina Faso in 2003 to that in 2009?
Give a very brief answer. 1.15. What is the ratio of the Tax (as % of total tax revenue) of Iceland in 2003 to that in 2009?
Offer a terse response. 0.86. What is the ratio of the Tax (as % of total tax revenue) of Mali in 2003 to that in 2009?
Provide a short and direct response. 0.74. What is the ratio of the Tax (as % of total tax revenue) of Moldova in 2003 to that in 2009?
Keep it short and to the point. 3.05. What is the ratio of the Tax (as % of total tax revenue) of Burkina Faso in 2004 to that in 2005?
Ensure brevity in your answer.  0.95. What is the ratio of the Tax (as % of total tax revenue) of Iceland in 2004 to that in 2005?
Ensure brevity in your answer.  0.95. What is the ratio of the Tax (as % of total tax revenue) in Mali in 2004 to that in 2005?
Give a very brief answer. 0.88. What is the ratio of the Tax (as % of total tax revenue) in Moldova in 2004 to that in 2005?
Provide a short and direct response. 1.24. What is the ratio of the Tax (as % of total tax revenue) of Burkina Faso in 2004 to that in 2006?
Give a very brief answer. 0.96. What is the ratio of the Tax (as % of total tax revenue) of Iceland in 2004 to that in 2006?
Keep it short and to the point. 0.89. What is the ratio of the Tax (as % of total tax revenue) of Mali in 2004 to that in 2006?
Your answer should be compact. 0.99. What is the ratio of the Tax (as % of total tax revenue) in Moldova in 2004 to that in 2006?
Provide a short and direct response. 1.12. What is the ratio of the Tax (as % of total tax revenue) in Burkina Faso in 2004 to that in 2007?
Your answer should be compact. 0.94. What is the ratio of the Tax (as % of total tax revenue) in Iceland in 2004 to that in 2007?
Give a very brief answer. 0.87. What is the ratio of the Tax (as % of total tax revenue) in Mali in 2004 to that in 2007?
Offer a terse response. 0.86. What is the ratio of the Tax (as % of total tax revenue) in Moldova in 2004 to that in 2007?
Your response must be concise. 0.92. What is the ratio of the Tax (as % of total tax revenue) in Burkina Faso in 2004 to that in 2008?
Offer a very short reply. 0.96. What is the ratio of the Tax (as % of total tax revenue) of Iceland in 2004 to that in 2008?
Make the answer very short. 0.79. What is the ratio of the Tax (as % of total tax revenue) of Mali in 2004 to that in 2008?
Your answer should be compact. 0.62. What is the ratio of the Tax (as % of total tax revenue) of Moldova in 2004 to that in 2008?
Your answer should be compact. 2.28. What is the ratio of the Tax (as % of total tax revenue) in Burkina Faso in 2004 to that in 2009?
Make the answer very short. 1.04. What is the ratio of the Tax (as % of total tax revenue) in Iceland in 2004 to that in 2009?
Offer a terse response. 0.84. What is the ratio of the Tax (as % of total tax revenue) of Mali in 2004 to that in 2009?
Your answer should be compact. 0.63. What is the ratio of the Tax (as % of total tax revenue) in Moldova in 2004 to that in 2009?
Provide a short and direct response. 3.14. What is the ratio of the Tax (as % of total tax revenue) in Burkina Faso in 2005 to that in 2006?
Ensure brevity in your answer.  1.01. What is the ratio of the Tax (as % of total tax revenue) of Iceland in 2005 to that in 2006?
Your response must be concise. 0.94. What is the ratio of the Tax (as % of total tax revenue) in Mali in 2005 to that in 2006?
Give a very brief answer. 1.13. What is the ratio of the Tax (as % of total tax revenue) of Moldova in 2005 to that in 2006?
Provide a short and direct response. 0.9. What is the ratio of the Tax (as % of total tax revenue) in Burkina Faso in 2005 to that in 2007?
Keep it short and to the point. 0.99. What is the ratio of the Tax (as % of total tax revenue) in Iceland in 2005 to that in 2007?
Provide a succinct answer. 0.91. What is the ratio of the Tax (as % of total tax revenue) in Mali in 2005 to that in 2007?
Your response must be concise. 0.98. What is the ratio of the Tax (as % of total tax revenue) of Moldova in 2005 to that in 2007?
Provide a short and direct response. 0.74. What is the ratio of the Tax (as % of total tax revenue) of Burkina Faso in 2005 to that in 2008?
Keep it short and to the point. 1.01. What is the ratio of the Tax (as % of total tax revenue) in Iceland in 2005 to that in 2008?
Your answer should be very brief. 0.84. What is the ratio of the Tax (as % of total tax revenue) of Mali in 2005 to that in 2008?
Provide a short and direct response. 0.71. What is the ratio of the Tax (as % of total tax revenue) of Moldova in 2005 to that in 2008?
Offer a terse response. 1.84. What is the ratio of the Tax (as % of total tax revenue) in Iceland in 2005 to that in 2009?
Provide a short and direct response. 0.89. What is the ratio of the Tax (as % of total tax revenue) of Mali in 2005 to that in 2009?
Provide a short and direct response. 0.72. What is the ratio of the Tax (as % of total tax revenue) in Moldova in 2005 to that in 2009?
Offer a very short reply. 2.53. What is the ratio of the Tax (as % of total tax revenue) of Burkina Faso in 2006 to that in 2007?
Your response must be concise. 0.98. What is the ratio of the Tax (as % of total tax revenue) of Iceland in 2006 to that in 2007?
Provide a short and direct response. 0.97. What is the ratio of the Tax (as % of total tax revenue) in Mali in 2006 to that in 2007?
Your answer should be very brief. 0.87. What is the ratio of the Tax (as % of total tax revenue) in Moldova in 2006 to that in 2007?
Offer a very short reply. 0.82. What is the ratio of the Tax (as % of total tax revenue) of Iceland in 2006 to that in 2008?
Provide a succinct answer. 0.89. What is the ratio of the Tax (as % of total tax revenue) of Mali in 2006 to that in 2008?
Provide a succinct answer. 0.63. What is the ratio of the Tax (as % of total tax revenue) of Moldova in 2006 to that in 2008?
Offer a very short reply. 2.05. What is the ratio of the Tax (as % of total tax revenue) in Burkina Faso in 2006 to that in 2009?
Offer a terse response. 1.08. What is the ratio of the Tax (as % of total tax revenue) in Iceland in 2006 to that in 2009?
Your answer should be compact. 0.95. What is the ratio of the Tax (as % of total tax revenue) in Mali in 2006 to that in 2009?
Offer a very short reply. 0.64. What is the ratio of the Tax (as % of total tax revenue) in Moldova in 2006 to that in 2009?
Make the answer very short. 2.82. What is the ratio of the Tax (as % of total tax revenue) of Burkina Faso in 2007 to that in 2008?
Your answer should be very brief. 1.02. What is the ratio of the Tax (as % of total tax revenue) in Iceland in 2007 to that in 2008?
Ensure brevity in your answer.  0.92. What is the ratio of the Tax (as % of total tax revenue) of Mali in 2007 to that in 2008?
Your answer should be compact. 0.73. What is the ratio of the Tax (as % of total tax revenue) of Moldova in 2007 to that in 2008?
Make the answer very short. 2.49. What is the ratio of the Tax (as % of total tax revenue) in Burkina Faso in 2007 to that in 2009?
Provide a short and direct response. 1.11. What is the ratio of the Tax (as % of total tax revenue) of Iceland in 2007 to that in 2009?
Your response must be concise. 0.97. What is the ratio of the Tax (as % of total tax revenue) of Mali in 2007 to that in 2009?
Your response must be concise. 0.74. What is the ratio of the Tax (as % of total tax revenue) in Moldova in 2007 to that in 2009?
Ensure brevity in your answer.  3.42. What is the ratio of the Tax (as % of total tax revenue) in Burkina Faso in 2008 to that in 2009?
Your response must be concise. 1.08. What is the ratio of the Tax (as % of total tax revenue) of Iceland in 2008 to that in 2009?
Offer a very short reply. 1.06. What is the ratio of the Tax (as % of total tax revenue) in Mali in 2008 to that in 2009?
Offer a very short reply. 1.02. What is the ratio of the Tax (as % of total tax revenue) of Moldova in 2008 to that in 2009?
Keep it short and to the point. 1.38. What is the difference between the highest and the second highest Tax (as % of total tax revenue) of Burkina Faso?
Ensure brevity in your answer.  0.96. What is the difference between the highest and the second highest Tax (as % of total tax revenue) in Iceland?
Keep it short and to the point. 2.58. What is the difference between the highest and the second highest Tax (as % of total tax revenue) of Mali?
Provide a short and direct response. 0.45. What is the difference between the highest and the second highest Tax (as % of total tax revenue) in Moldova?
Make the answer very short. 0.48. What is the difference between the highest and the lowest Tax (as % of total tax revenue) of Burkina Faso?
Give a very brief answer. 3.23. What is the difference between the highest and the lowest Tax (as % of total tax revenue) in Iceland?
Offer a very short reply. 8.97. What is the difference between the highest and the lowest Tax (as % of total tax revenue) of Mali?
Your answer should be compact. 10.9. What is the difference between the highest and the lowest Tax (as % of total tax revenue) of Moldova?
Keep it short and to the point. 4.15. 